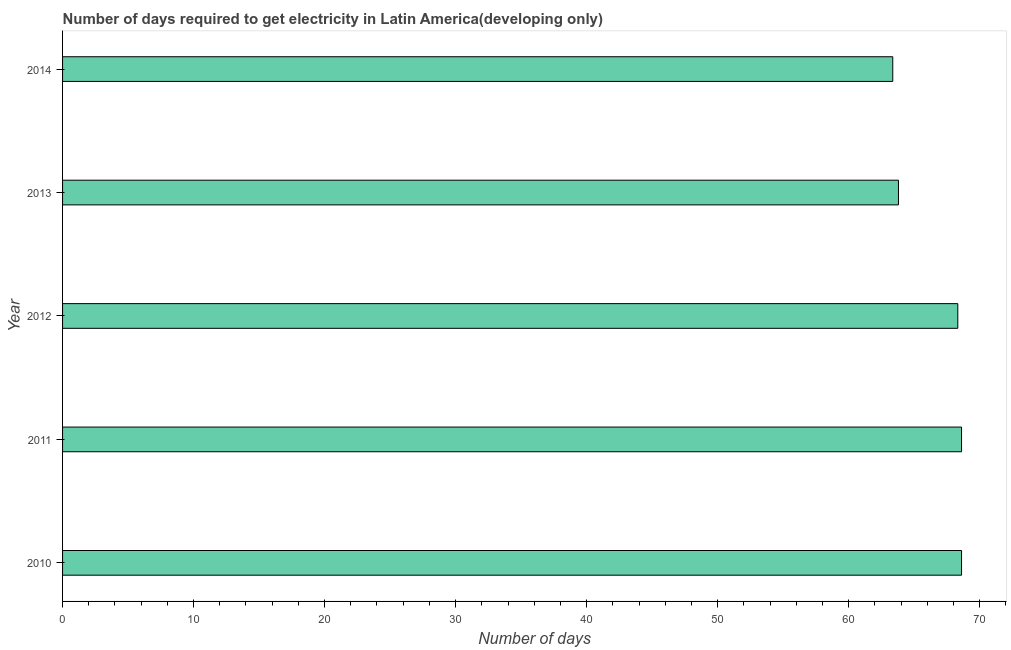What is the title of the graph?
Ensure brevity in your answer.  Number of days required to get electricity in Latin America(developing only). What is the label or title of the X-axis?
Your answer should be very brief. Number of days. What is the label or title of the Y-axis?
Keep it short and to the point. Year. What is the time to get electricity in 2012?
Offer a very short reply. 68.33. Across all years, what is the maximum time to get electricity?
Offer a very short reply. 68.62. Across all years, what is the minimum time to get electricity?
Your answer should be very brief. 63.37. In which year was the time to get electricity maximum?
Your response must be concise. 2010. What is the sum of the time to get electricity?
Your answer should be compact. 332.75. What is the difference between the time to get electricity in 2010 and 2013?
Provide a short and direct response. 4.82. What is the average time to get electricity per year?
Offer a terse response. 66.55. What is the median time to get electricity?
Make the answer very short. 68.33. What is the ratio of the time to get electricity in 2011 to that in 2013?
Make the answer very short. 1.07. Is the difference between the time to get electricity in 2011 and 2012 greater than the difference between any two years?
Give a very brief answer. No. Is the sum of the time to get electricity in 2012 and 2013 greater than the maximum time to get electricity across all years?
Offer a terse response. Yes. What is the difference between the highest and the lowest time to get electricity?
Your response must be concise. 5.25. How many bars are there?
Keep it short and to the point. 5. How many years are there in the graph?
Your answer should be compact. 5. What is the difference between two consecutive major ticks on the X-axis?
Make the answer very short. 10. What is the Number of days of 2010?
Keep it short and to the point. 68.62. What is the Number of days of 2011?
Your response must be concise. 68.62. What is the Number of days in 2012?
Your answer should be very brief. 68.33. What is the Number of days of 2013?
Ensure brevity in your answer.  63.8. What is the Number of days in 2014?
Keep it short and to the point. 63.37. What is the difference between the Number of days in 2010 and 2011?
Keep it short and to the point. 0. What is the difference between the Number of days in 2010 and 2012?
Give a very brief answer. 0.29. What is the difference between the Number of days in 2010 and 2013?
Give a very brief answer. 4.81. What is the difference between the Number of days in 2010 and 2014?
Provide a short and direct response. 5.25. What is the difference between the Number of days in 2011 and 2012?
Your response must be concise. 0.29. What is the difference between the Number of days in 2011 and 2013?
Provide a succinct answer. 4.81. What is the difference between the Number of days in 2011 and 2014?
Offer a terse response. 5.25. What is the difference between the Number of days in 2012 and 2013?
Keep it short and to the point. 4.53. What is the difference between the Number of days in 2012 and 2014?
Provide a succinct answer. 4.96. What is the difference between the Number of days in 2013 and 2014?
Give a very brief answer. 0.43. What is the ratio of the Number of days in 2010 to that in 2013?
Make the answer very short. 1.07. What is the ratio of the Number of days in 2010 to that in 2014?
Offer a very short reply. 1.08. What is the ratio of the Number of days in 2011 to that in 2013?
Keep it short and to the point. 1.07. What is the ratio of the Number of days in 2011 to that in 2014?
Offer a terse response. 1.08. What is the ratio of the Number of days in 2012 to that in 2013?
Provide a succinct answer. 1.07. What is the ratio of the Number of days in 2012 to that in 2014?
Give a very brief answer. 1.08. What is the ratio of the Number of days in 2013 to that in 2014?
Ensure brevity in your answer.  1.01. 